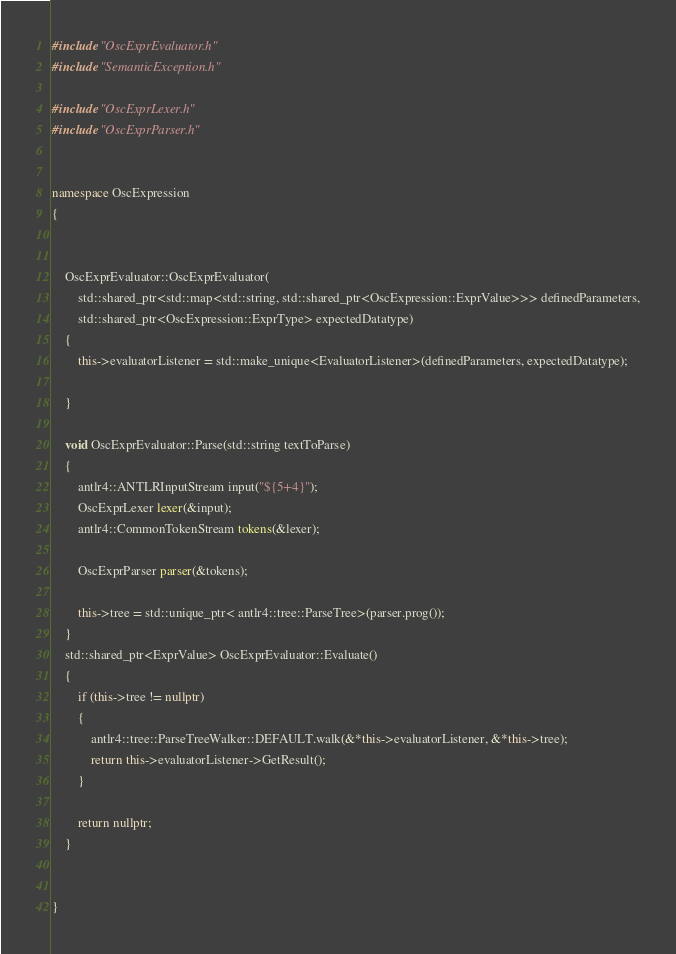<code> <loc_0><loc_0><loc_500><loc_500><_C++_>#include "OscExprEvaluator.h"
#include "SemanticException.h"

#include "OscExprLexer.h"
#include "OscExprParser.h"


namespace OscExpression
{	
	

	OscExprEvaluator::OscExprEvaluator(
		std::shared_ptr<std::map<std::string, std::shared_ptr<OscExpression::ExprValue>>> definedParameters,
		std::shared_ptr<OscExpression::ExprType> expectedDatatype)
	{
		this->evaluatorListener = std::make_unique<EvaluatorListener>(definedParameters, expectedDatatype);
		
	}

	void OscExprEvaluator::Parse(std::string textToParse)
	{
		antlr4::ANTLRInputStream input("${5+4}");
		OscExprLexer lexer(&input);
		antlr4::CommonTokenStream tokens(&lexer);

		OscExprParser parser(&tokens);
		
		this->tree = std::unique_ptr< antlr4::tree::ParseTree>(parser.prog());
	}
	std::shared_ptr<ExprValue> OscExprEvaluator::Evaluate()
	{
		if (this->tree != nullptr)
		{
			antlr4::tree::ParseTreeWalker::DEFAULT.walk(&*this->evaluatorListener, &*this->tree);
			return this->evaluatorListener->GetResult();
		}

		return nullptr;
	}


}
</code> 